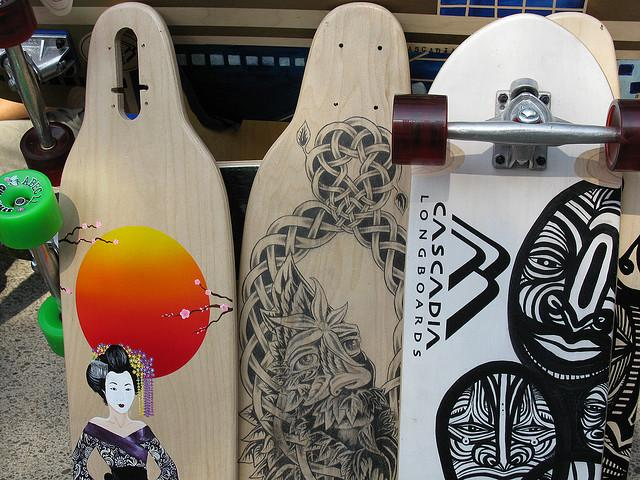This board is used for what sport? Please explain your reasoning. skateboarding. The board is for skateboarding. 